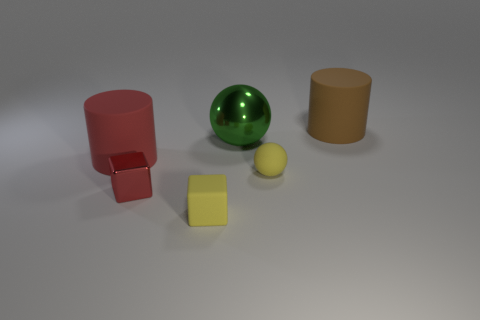Add 1 red shiny balls. How many objects exist? 7 Subtract all spheres. How many objects are left? 4 Add 1 green shiny spheres. How many green shiny spheres exist? 2 Subtract 0 blue spheres. How many objects are left? 6 Subtract all large gray matte cylinders. Subtract all shiny objects. How many objects are left? 4 Add 2 tiny red shiny cubes. How many tiny red shiny cubes are left? 3 